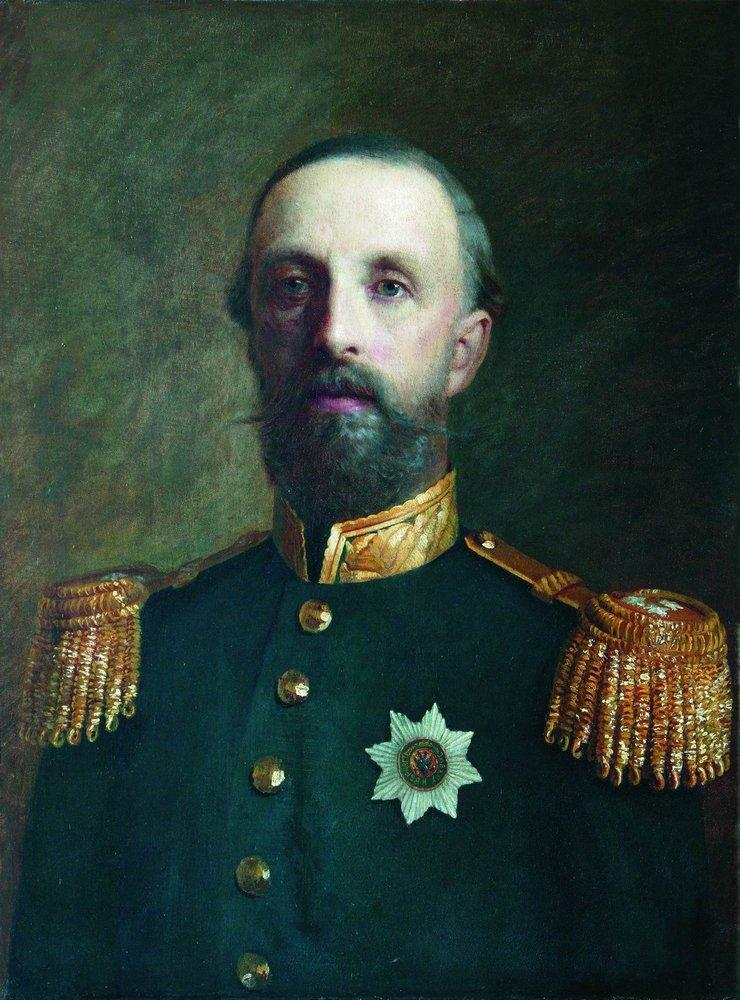Can you describe the attire of the man? Certainly! The man in the portrait is wearing a dark blue military uniform, adorned with gold epaulettes on the shoulders that signify his high-ranking position. His jacket is buttoned up and features golden buttons, adding a touch of opulence to his attire. On his chest, he wears a large white star, which likely represents a prestigious award or a mark of distinction. What might the white star on his chest symbolize? The white star on the man's chest is likely a medal or an insignia of honor, indicating his rank, achievements, or acts of valor. Such decorations are often bestowed upon individuals who have demonstrated exceptional service or bravery, particularly in military contexts. The intricacies and prominence of the star suggest it holds significant importance and reflects the esteem in which the man is held. 